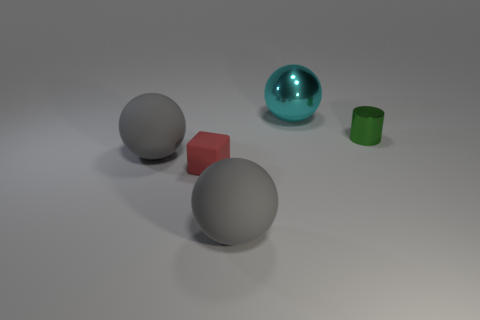There is a small thing left of the big cyan shiny sphere; what is its color?
Keep it short and to the point. Red. Does the cube have the same color as the small cylinder?
Keep it short and to the point. No. There is a object right of the big sphere behind the small green metal cylinder; what number of tiny green cylinders are on the right side of it?
Provide a short and direct response. 0. The metal cylinder is what size?
Your answer should be very brief. Small. There is a green thing that is the same size as the red matte thing; what material is it?
Your response must be concise. Metal. What number of big metal spheres are on the right side of the shiny cylinder?
Provide a succinct answer. 0. Is the material of the object that is right of the cyan shiny thing the same as the tiny thing on the left side of the metal sphere?
Offer a very short reply. No. What shape is the shiny thing behind the metallic thing that is in front of the thing that is behind the small shiny cylinder?
Provide a short and direct response. Sphere. The tiny red thing has what shape?
Offer a very short reply. Cube. There is a red object that is the same size as the green cylinder; what shape is it?
Your answer should be compact. Cube. 